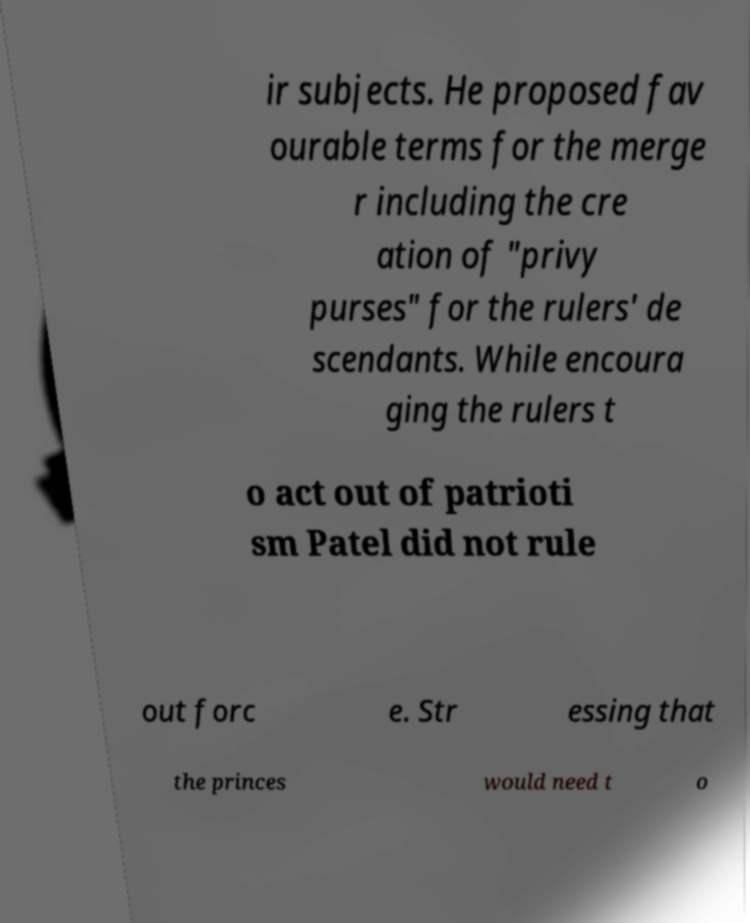For documentation purposes, I need the text within this image transcribed. Could you provide that? ir subjects. He proposed fav ourable terms for the merge r including the cre ation of "privy purses" for the rulers' de scendants. While encoura ging the rulers t o act out of patrioti sm Patel did not rule out forc e. Str essing that the princes would need t o 